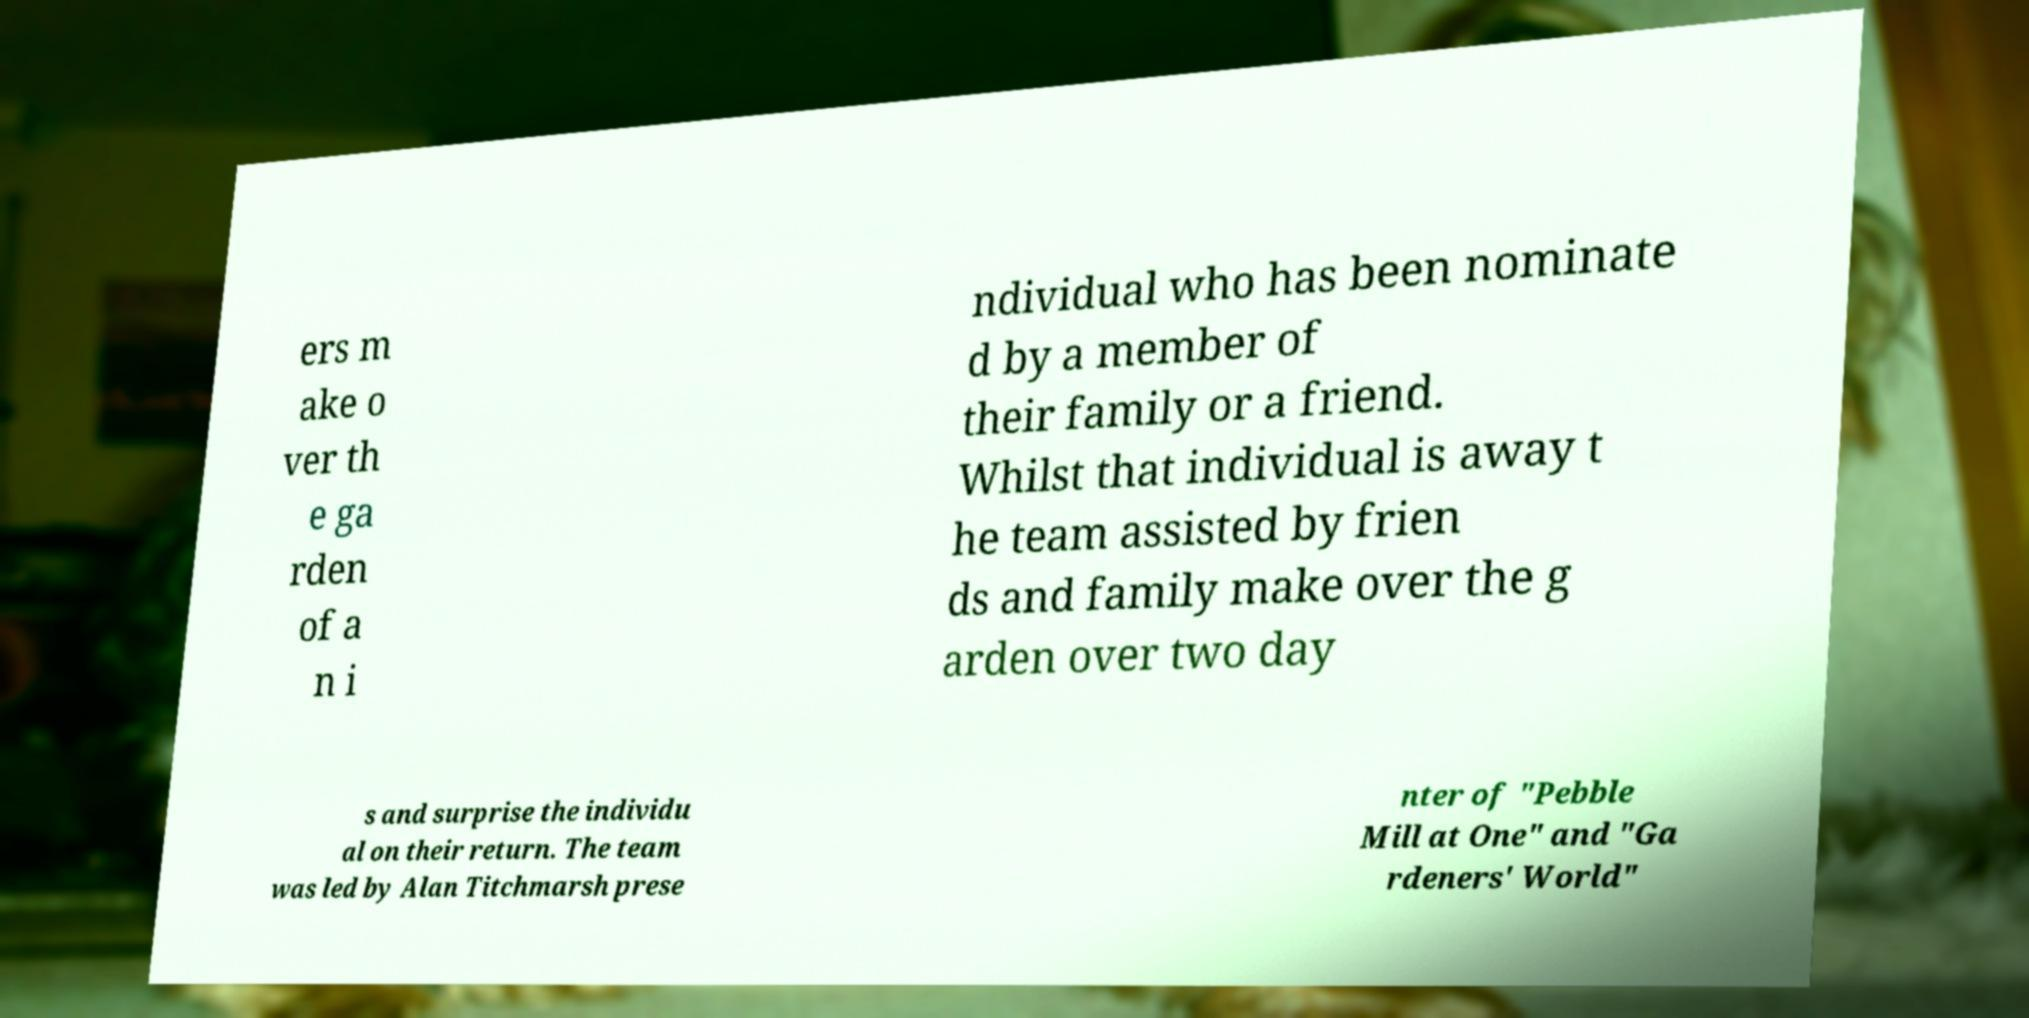Please identify and transcribe the text found in this image. ers m ake o ver th e ga rden of a n i ndividual who has been nominate d by a member of their family or a friend. Whilst that individual is away t he team assisted by frien ds and family make over the g arden over two day s and surprise the individu al on their return. The team was led by Alan Titchmarsh prese nter of "Pebble Mill at One" and "Ga rdeners' World" 